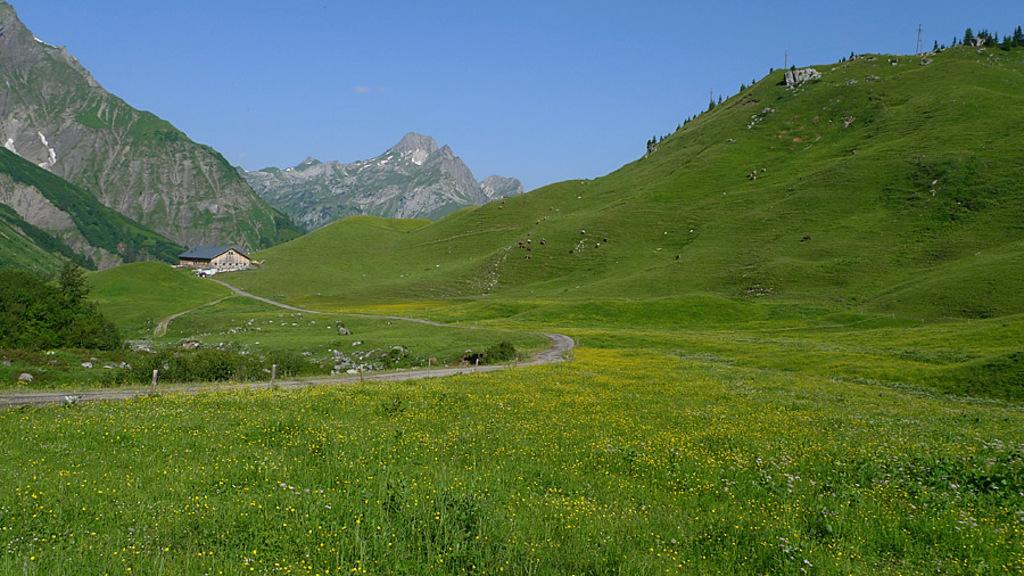What type of vegetation can be seen in the image? There are plants and flowers in the image. What type of structure is visible in the image? There is a house in the image. What type of terrain is present in the image? There are hills in the image. What can be seen in the background of the image? The sky is visible in the background of the image. What type of loaf is being baked in the image? There is no loaf or baking activity present in the image. How does the carpenter use the sidewalk in the image? There is no carpenter or sidewalk present in the image. 